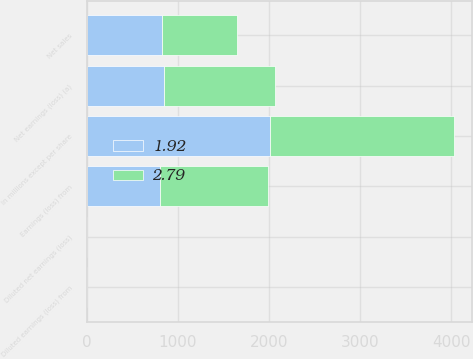<chart> <loc_0><loc_0><loc_500><loc_500><stacked_bar_chart><ecel><fcel>In millions except per share<fcel>Net sales<fcel>Earnings (loss) from<fcel>Net earnings (loss) (a)<fcel>Diluted earnings (loss) from<fcel>Diluted net earnings (loss)<nl><fcel>1.92<fcel>2012<fcel>825<fcel>805<fcel>845<fcel>1.82<fcel>1.92<nl><fcel>2.79<fcel>2011<fcel>825<fcel>1185<fcel>1220<fcel>2.68<fcel>2.79<nl></chart> 